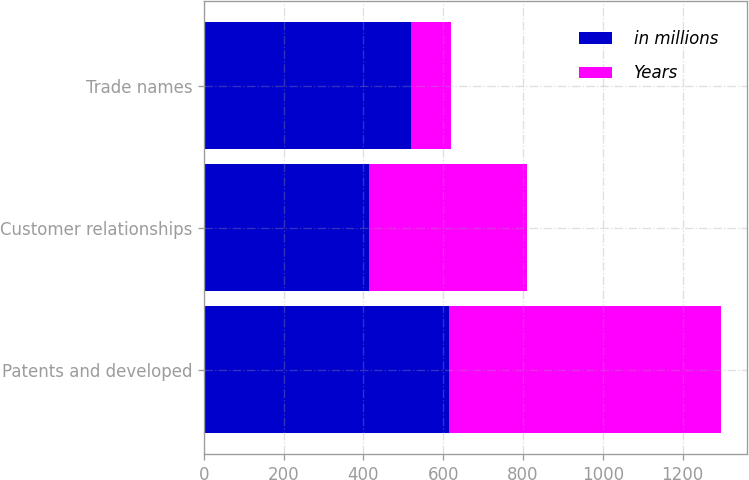<chart> <loc_0><loc_0><loc_500><loc_500><stacked_bar_chart><ecel><fcel>Patents and developed<fcel>Customer relationships<fcel>Trade names<nl><fcel>in millions<fcel>615<fcel>414<fcel>520<nl><fcel>Years<fcel>681<fcel>396<fcel>99<nl></chart> 